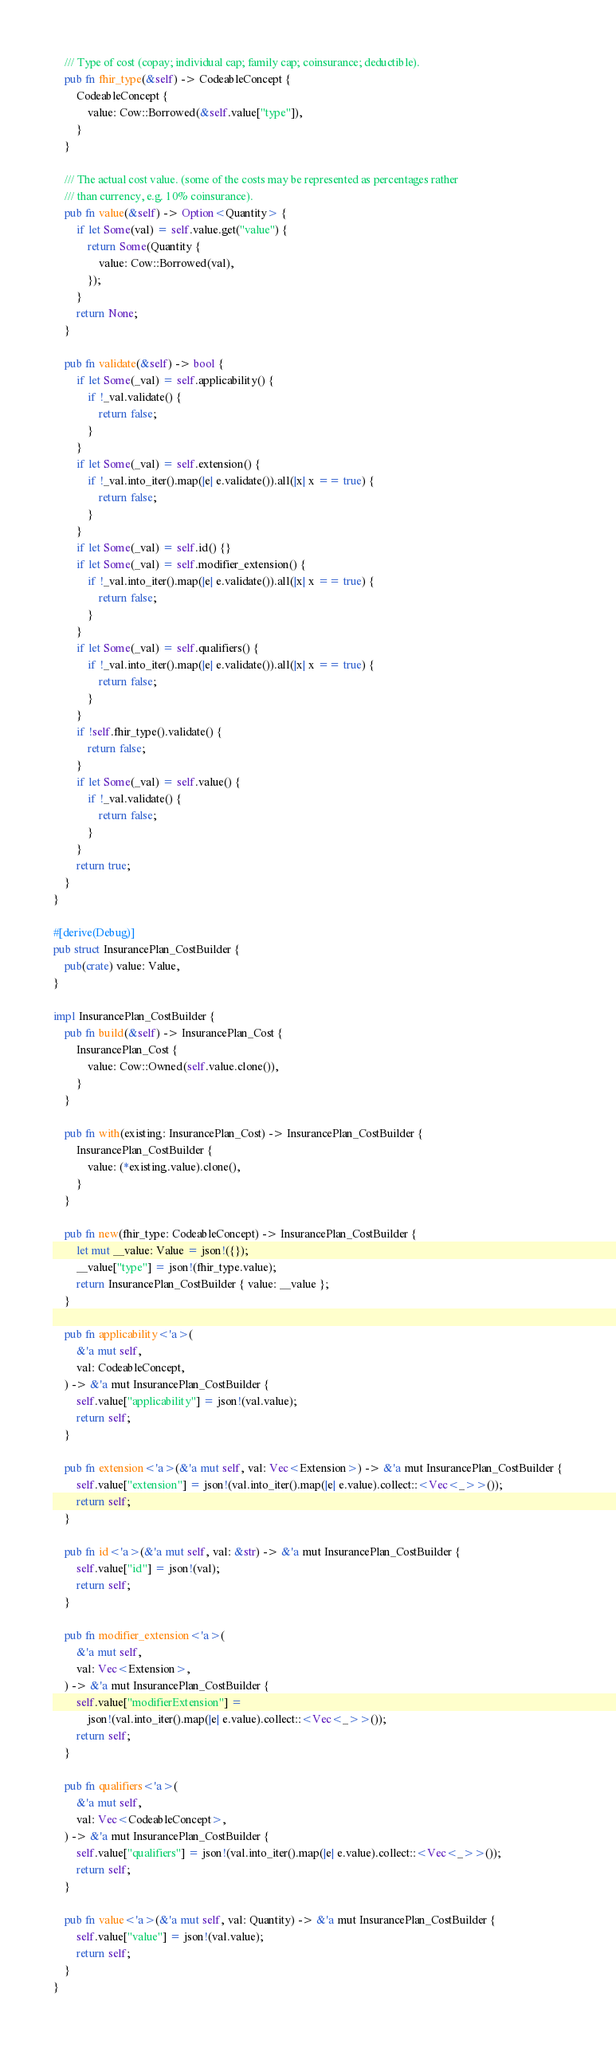Convert code to text. <code><loc_0><loc_0><loc_500><loc_500><_Rust_>
    /// Type of cost (copay; individual cap; family cap; coinsurance; deductible).
    pub fn fhir_type(&self) -> CodeableConcept {
        CodeableConcept {
            value: Cow::Borrowed(&self.value["type"]),
        }
    }

    /// The actual cost value. (some of the costs may be represented as percentages rather
    /// than currency, e.g. 10% coinsurance).
    pub fn value(&self) -> Option<Quantity> {
        if let Some(val) = self.value.get("value") {
            return Some(Quantity {
                value: Cow::Borrowed(val),
            });
        }
        return None;
    }

    pub fn validate(&self) -> bool {
        if let Some(_val) = self.applicability() {
            if !_val.validate() {
                return false;
            }
        }
        if let Some(_val) = self.extension() {
            if !_val.into_iter().map(|e| e.validate()).all(|x| x == true) {
                return false;
            }
        }
        if let Some(_val) = self.id() {}
        if let Some(_val) = self.modifier_extension() {
            if !_val.into_iter().map(|e| e.validate()).all(|x| x == true) {
                return false;
            }
        }
        if let Some(_val) = self.qualifiers() {
            if !_val.into_iter().map(|e| e.validate()).all(|x| x == true) {
                return false;
            }
        }
        if !self.fhir_type().validate() {
            return false;
        }
        if let Some(_val) = self.value() {
            if !_val.validate() {
                return false;
            }
        }
        return true;
    }
}

#[derive(Debug)]
pub struct InsurancePlan_CostBuilder {
    pub(crate) value: Value,
}

impl InsurancePlan_CostBuilder {
    pub fn build(&self) -> InsurancePlan_Cost {
        InsurancePlan_Cost {
            value: Cow::Owned(self.value.clone()),
        }
    }

    pub fn with(existing: InsurancePlan_Cost) -> InsurancePlan_CostBuilder {
        InsurancePlan_CostBuilder {
            value: (*existing.value).clone(),
        }
    }

    pub fn new(fhir_type: CodeableConcept) -> InsurancePlan_CostBuilder {
        let mut __value: Value = json!({});
        __value["type"] = json!(fhir_type.value);
        return InsurancePlan_CostBuilder { value: __value };
    }

    pub fn applicability<'a>(
        &'a mut self,
        val: CodeableConcept,
    ) -> &'a mut InsurancePlan_CostBuilder {
        self.value["applicability"] = json!(val.value);
        return self;
    }

    pub fn extension<'a>(&'a mut self, val: Vec<Extension>) -> &'a mut InsurancePlan_CostBuilder {
        self.value["extension"] = json!(val.into_iter().map(|e| e.value).collect::<Vec<_>>());
        return self;
    }

    pub fn id<'a>(&'a mut self, val: &str) -> &'a mut InsurancePlan_CostBuilder {
        self.value["id"] = json!(val);
        return self;
    }

    pub fn modifier_extension<'a>(
        &'a mut self,
        val: Vec<Extension>,
    ) -> &'a mut InsurancePlan_CostBuilder {
        self.value["modifierExtension"] =
            json!(val.into_iter().map(|e| e.value).collect::<Vec<_>>());
        return self;
    }

    pub fn qualifiers<'a>(
        &'a mut self,
        val: Vec<CodeableConcept>,
    ) -> &'a mut InsurancePlan_CostBuilder {
        self.value["qualifiers"] = json!(val.into_iter().map(|e| e.value).collect::<Vec<_>>());
        return self;
    }

    pub fn value<'a>(&'a mut self, val: Quantity) -> &'a mut InsurancePlan_CostBuilder {
        self.value["value"] = json!(val.value);
        return self;
    }
}
</code> 